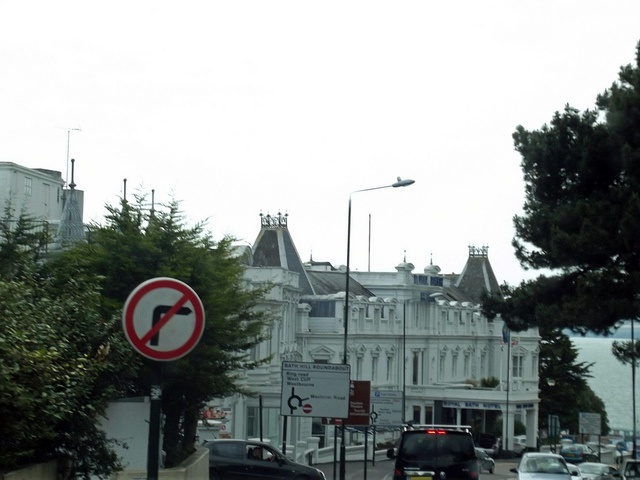Describe the objects in this image and their specific colors. I can see potted plant in white, black, gray, and darkgreen tones, potted plant in white, black, gray, and darkgreen tones, car in white, black, gray, purple, and brown tones, truck in white, black, gray, and purple tones, and car in white, black, gray, purple, and darkblue tones in this image. 